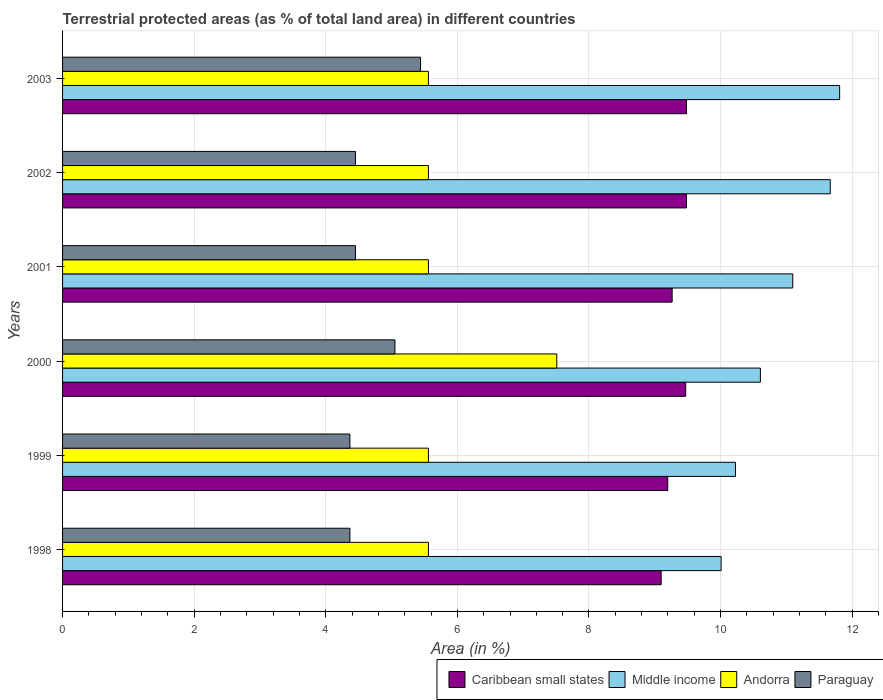How many groups of bars are there?
Keep it short and to the point. 6. Are the number of bars per tick equal to the number of legend labels?
Your answer should be very brief. Yes. How many bars are there on the 5th tick from the top?
Your answer should be very brief. 4. What is the label of the 2nd group of bars from the top?
Your answer should be very brief. 2002. In how many cases, is the number of bars for a given year not equal to the number of legend labels?
Provide a short and direct response. 0. What is the percentage of terrestrial protected land in Paraguay in 2003?
Provide a short and direct response. 5.44. Across all years, what is the maximum percentage of terrestrial protected land in Middle income?
Your answer should be compact. 11.81. Across all years, what is the minimum percentage of terrestrial protected land in Middle income?
Ensure brevity in your answer.  10.01. What is the total percentage of terrestrial protected land in Middle income in the graph?
Offer a terse response. 65.41. What is the difference between the percentage of terrestrial protected land in Andorra in 2000 and the percentage of terrestrial protected land in Middle income in 1999?
Make the answer very short. -2.72. What is the average percentage of terrestrial protected land in Caribbean small states per year?
Give a very brief answer. 9.33. In the year 2000, what is the difference between the percentage of terrestrial protected land in Middle income and percentage of terrestrial protected land in Andorra?
Your response must be concise. 3.09. In how many years, is the percentage of terrestrial protected land in Caribbean small states greater than 6.8 %?
Offer a terse response. 6. What is the ratio of the percentage of terrestrial protected land in Middle income in 1998 to that in 2003?
Offer a very short reply. 0.85. Is the percentage of terrestrial protected land in Caribbean small states in 2000 less than that in 2003?
Offer a very short reply. Yes. Is the difference between the percentage of terrestrial protected land in Middle income in 1998 and 2001 greater than the difference between the percentage of terrestrial protected land in Andorra in 1998 and 2001?
Keep it short and to the point. No. What is the difference between the highest and the second highest percentage of terrestrial protected land in Paraguay?
Your response must be concise. 0.39. What is the difference between the highest and the lowest percentage of terrestrial protected land in Andorra?
Provide a succinct answer. 1.95. What does the 2nd bar from the top in 2003 represents?
Make the answer very short. Andorra. What does the 4th bar from the bottom in 2001 represents?
Your response must be concise. Paraguay. Is it the case that in every year, the sum of the percentage of terrestrial protected land in Middle income and percentage of terrestrial protected land in Andorra is greater than the percentage of terrestrial protected land in Caribbean small states?
Provide a succinct answer. Yes. How many bars are there?
Give a very brief answer. 24. Are all the bars in the graph horizontal?
Give a very brief answer. Yes. Does the graph contain grids?
Offer a very short reply. Yes. Where does the legend appear in the graph?
Your response must be concise. Bottom right. What is the title of the graph?
Offer a very short reply. Terrestrial protected areas (as % of total land area) in different countries. Does "European Union" appear as one of the legend labels in the graph?
Your answer should be compact. No. What is the label or title of the X-axis?
Your answer should be very brief. Area (in %). What is the label or title of the Y-axis?
Your response must be concise. Years. What is the Area (in %) of Caribbean small states in 1998?
Offer a very short reply. 9.1. What is the Area (in %) of Middle income in 1998?
Provide a short and direct response. 10.01. What is the Area (in %) of Andorra in 1998?
Your answer should be compact. 5.56. What is the Area (in %) of Paraguay in 1998?
Make the answer very short. 4.37. What is the Area (in %) in Caribbean small states in 1999?
Ensure brevity in your answer.  9.2. What is the Area (in %) in Middle income in 1999?
Provide a succinct answer. 10.23. What is the Area (in %) in Andorra in 1999?
Offer a very short reply. 5.56. What is the Area (in %) of Paraguay in 1999?
Offer a very short reply. 4.37. What is the Area (in %) in Caribbean small states in 2000?
Provide a short and direct response. 9.47. What is the Area (in %) in Middle income in 2000?
Ensure brevity in your answer.  10.61. What is the Area (in %) of Andorra in 2000?
Ensure brevity in your answer.  7.51. What is the Area (in %) of Paraguay in 2000?
Keep it short and to the point. 5.05. What is the Area (in %) of Caribbean small states in 2001?
Your answer should be very brief. 9.26. What is the Area (in %) in Middle income in 2001?
Provide a succinct answer. 11.1. What is the Area (in %) in Andorra in 2001?
Offer a terse response. 5.56. What is the Area (in %) in Paraguay in 2001?
Make the answer very short. 4.45. What is the Area (in %) of Caribbean small states in 2002?
Ensure brevity in your answer.  9.48. What is the Area (in %) of Middle income in 2002?
Your answer should be compact. 11.67. What is the Area (in %) of Andorra in 2002?
Ensure brevity in your answer.  5.56. What is the Area (in %) of Paraguay in 2002?
Offer a very short reply. 4.45. What is the Area (in %) of Caribbean small states in 2003?
Offer a terse response. 9.48. What is the Area (in %) of Middle income in 2003?
Offer a very short reply. 11.81. What is the Area (in %) in Andorra in 2003?
Provide a succinct answer. 5.56. What is the Area (in %) in Paraguay in 2003?
Keep it short and to the point. 5.44. Across all years, what is the maximum Area (in %) in Caribbean small states?
Ensure brevity in your answer.  9.48. Across all years, what is the maximum Area (in %) of Middle income?
Offer a very short reply. 11.81. Across all years, what is the maximum Area (in %) in Andorra?
Ensure brevity in your answer.  7.51. Across all years, what is the maximum Area (in %) in Paraguay?
Your answer should be compact. 5.44. Across all years, what is the minimum Area (in %) in Caribbean small states?
Offer a very short reply. 9.1. Across all years, what is the minimum Area (in %) in Middle income?
Your answer should be very brief. 10.01. Across all years, what is the minimum Area (in %) in Andorra?
Your response must be concise. 5.56. Across all years, what is the minimum Area (in %) in Paraguay?
Give a very brief answer. 4.37. What is the total Area (in %) in Caribbean small states in the graph?
Ensure brevity in your answer.  55.99. What is the total Area (in %) in Middle income in the graph?
Keep it short and to the point. 65.41. What is the total Area (in %) of Andorra in the graph?
Give a very brief answer. 35.31. What is the total Area (in %) in Paraguay in the graph?
Your answer should be compact. 28.13. What is the difference between the Area (in %) of Caribbean small states in 1998 and that in 1999?
Offer a very short reply. -0.1. What is the difference between the Area (in %) of Middle income in 1998 and that in 1999?
Keep it short and to the point. -0.22. What is the difference between the Area (in %) of Caribbean small states in 1998 and that in 2000?
Give a very brief answer. -0.37. What is the difference between the Area (in %) in Middle income in 1998 and that in 2000?
Ensure brevity in your answer.  -0.6. What is the difference between the Area (in %) of Andorra in 1998 and that in 2000?
Your response must be concise. -1.95. What is the difference between the Area (in %) of Paraguay in 1998 and that in 2000?
Provide a short and direct response. -0.68. What is the difference between the Area (in %) in Caribbean small states in 1998 and that in 2001?
Make the answer very short. -0.17. What is the difference between the Area (in %) of Middle income in 1998 and that in 2001?
Your answer should be very brief. -1.09. What is the difference between the Area (in %) in Andorra in 1998 and that in 2001?
Offer a very short reply. 0. What is the difference between the Area (in %) in Paraguay in 1998 and that in 2001?
Offer a terse response. -0.08. What is the difference between the Area (in %) of Caribbean small states in 1998 and that in 2002?
Ensure brevity in your answer.  -0.39. What is the difference between the Area (in %) in Middle income in 1998 and that in 2002?
Your answer should be very brief. -1.66. What is the difference between the Area (in %) in Paraguay in 1998 and that in 2002?
Your answer should be very brief. -0.08. What is the difference between the Area (in %) in Caribbean small states in 1998 and that in 2003?
Keep it short and to the point. -0.39. What is the difference between the Area (in %) in Middle income in 1998 and that in 2003?
Your response must be concise. -1.8. What is the difference between the Area (in %) of Andorra in 1998 and that in 2003?
Offer a very short reply. 0. What is the difference between the Area (in %) in Paraguay in 1998 and that in 2003?
Offer a terse response. -1.07. What is the difference between the Area (in %) of Caribbean small states in 1999 and that in 2000?
Provide a succinct answer. -0.27. What is the difference between the Area (in %) of Middle income in 1999 and that in 2000?
Make the answer very short. -0.38. What is the difference between the Area (in %) of Andorra in 1999 and that in 2000?
Provide a short and direct response. -1.95. What is the difference between the Area (in %) of Paraguay in 1999 and that in 2000?
Ensure brevity in your answer.  -0.68. What is the difference between the Area (in %) of Caribbean small states in 1999 and that in 2001?
Offer a very short reply. -0.07. What is the difference between the Area (in %) in Middle income in 1999 and that in 2001?
Offer a very short reply. -0.87. What is the difference between the Area (in %) in Paraguay in 1999 and that in 2001?
Your answer should be very brief. -0.08. What is the difference between the Area (in %) of Caribbean small states in 1999 and that in 2002?
Offer a terse response. -0.28. What is the difference between the Area (in %) in Middle income in 1999 and that in 2002?
Give a very brief answer. -1.44. What is the difference between the Area (in %) of Andorra in 1999 and that in 2002?
Your answer should be very brief. 0. What is the difference between the Area (in %) of Paraguay in 1999 and that in 2002?
Make the answer very short. -0.08. What is the difference between the Area (in %) in Caribbean small states in 1999 and that in 2003?
Your response must be concise. -0.28. What is the difference between the Area (in %) of Middle income in 1999 and that in 2003?
Provide a short and direct response. -1.58. What is the difference between the Area (in %) in Andorra in 1999 and that in 2003?
Offer a very short reply. 0. What is the difference between the Area (in %) of Paraguay in 1999 and that in 2003?
Provide a short and direct response. -1.07. What is the difference between the Area (in %) in Caribbean small states in 2000 and that in 2001?
Ensure brevity in your answer.  0.21. What is the difference between the Area (in %) in Middle income in 2000 and that in 2001?
Your answer should be compact. -0.49. What is the difference between the Area (in %) in Andorra in 2000 and that in 2001?
Your response must be concise. 1.95. What is the difference between the Area (in %) in Paraguay in 2000 and that in 2001?
Provide a succinct answer. 0.6. What is the difference between the Area (in %) of Caribbean small states in 2000 and that in 2002?
Give a very brief answer. -0.01. What is the difference between the Area (in %) in Middle income in 2000 and that in 2002?
Make the answer very short. -1.06. What is the difference between the Area (in %) of Andorra in 2000 and that in 2002?
Provide a succinct answer. 1.95. What is the difference between the Area (in %) of Paraguay in 2000 and that in 2002?
Ensure brevity in your answer.  0.6. What is the difference between the Area (in %) in Caribbean small states in 2000 and that in 2003?
Give a very brief answer. -0.01. What is the difference between the Area (in %) of Middle income in 2000 and that in 2003?
Ensure brevity in your answer.  -1.2. What is the difference between the Area (in %) of Andorra in 2000 and that in 2003?
Ensure brevity in your answer.  1.95. What is the difference between the Area (in %) in Paraguay in 2000 and that in 2003?
Ensure brevity in your answer.  -0.39. What is the difference between the Area (in %) of Caribbean small states in 2001 and that in 2002?
Offer a very short reply. -0.22. What is the difference between the Area (in %) of Middle income in 2001 and that in 2002?
Offer a terse response. -0.57. What is the difference between the Area (in %) of Paraguay in 2001 and that in 2002?
Provide a short and direct response. 0. What is the difference between the Area (in %) of Caribbean small states in 2001 and that in 2003?
Your answer should be very brief. -0.22. What is the difference between the Area (in %) in Middle income in 2001 and that in 2003?
Provide a succinct answer. -0.71. What is the difference between the Area (in %) in Paraguay in 2001 and that in 2003?
Provide a short and direct response. -0.99. What is the difference between the Area (in %) in Middle income in 2002 and that in 2003?
Keep it short and to the point. -0.14. What is the difference between the Area (in %) in Paraguay in 2002 and that in 2003?
Provide a succinct answer. -0.99. What is the difference between the Area (in %) of Caribbean small states in 1998 and the Area (in %) of Middle income in 1999?
Make the answer very short. -1.13. What is the difference between the Area (in %) of Caribbean small states in 1998 and the Area (in %) of Andorra in 1999?
Provide a short and direct response. 3.54. What is the difference between the Area (in %) in Caribbean small states in 1998 and the Area (in %) in Paraguay in 1999?
Your answer should be very brief. 4.73. What is the difference between the Area (in %) in Middle income in 1998 and the Area (in %) in Andorra in 1999?
Keep it short and to the point. 4.45. What is the difference between the Area (in %) in Middle income in 1998 and the Area (in %) in Paraguay in 1999?
Your response must be concise. 5.64. What is the difference between the Area (in %) in Andorra in 1998 and the Area (in %) in Paraguay in 1999?
Give a very brief answer. 1.19. What is the difference between the Area (in %) of Caribbean small states in 1998 and the Area (in %) of Middle income in 2000?
Provide a short and direct response. -1.51. What is the difference between the Area (in %) in Caribbean small states in 1998 and the Area (in %) in Andorra in 2000?
Offer a very short reply. 1.59. What is the difference between the Area (in %) of Caribbean small states in 1998 and the Area (in %) of Paraguay in 2000?
Give a very brief answer. 4.05. What is the difference between the Area (in %) in Middle income in 1998 and the Area (in %) in Andorra in 2000?
Your answer should be very brief. 2.5. What is the difference between the Area (in %) in Middle income in 1998 and the Area (in %) in Paraguay in 2000?
Offer a very short reply. 4.96. What is the difference between the Area (in %) in Andorra in 1998 and the Area (in %) in Paraguay in 2000?
Your answer should be compact. 0.51. What is the difference between the Area (in %) in Caribbean small states in 1998 and the Area (in %) in Middle income in 2001?
Provide a succinct answer. -2. What is the difference between the Area (in %) in Caribbean small states in 1998 and the Area (in %) in Andorra in 2001?
Your response must be concise. 3.54. What is the difference between the Area (in %) in Caribbean small states in 1998 and the Area (in %) in Paraguay in 2001?
Keep it short and to the point. 4.65. What is the difference between the Area (in %) in Middle income in 1998 and the Area (in %) in Andorra in 2001?
Give a very brief answer. 4.45. What is the difference between the Area (in %) in Middle income in 1998 and the Area (in %) in Paraguay in 2001?
Offer a very short reply. 5.56. What is the difference between the Area (in %) in Andorra in 1998 and the Area (in %) in Paraguay in 2001?
Offer a terse response. 1.11. What is the difference between the Area (in %) in Caribbean small states in 1998 and the Area (in %) in Middle income in 2002?
Give a very brief answer. -2.57. What is the difference between the Area (in %) of Caribbean small states in 1998 and the Area (in %) of Andorra in 2002?
Your response must be concise. 3.54. What is the difference between the Area (in %) in Caribbean small states in 1998 and the Area (in %) in Paraguay in 2002?
Keep it short and to the point. 4.65. What is the difference between the Area (in %) in Middle income in 1998 and the Area (in %) in Andorra in 2002?
Offer a terse response. 4.45. What is the difference between the Area (in %) in Middle income in 1998 and the Area (in %) in Paraguay in 2002?
Offer a terse response. 5.56. What is the difference between the Area (in %) of Andorra in 1998 and the Area (in %) of Paraguay in 2002?
Provide a succinct answer. 1.11. What is the difference between the Area (in %) in Caribbean small states in 1998 and the Area (in %) in Middle income in 2003?
Offer a very short reply. -2.71. What is the difference between the Area (in %) of Caribbean small states in 1998 and the Area (in %) of Andorra in 2003?
Offer a terse response. 3.54. What is the difference between the Area (in %) in Caribbean small states in 1998 and the Area (in %) in Paraguay in 2003?
Your answer should be compact. 3.66. What is the difference between the Area (in %) of Middle income in 1998 and the Area (in %) of Andorra in 2003?
Offer a terse response. 4.45. What is the difference between the Area (in %) of Middle income in 1998 and the Area (in %) of Paraguay in 2003?
Make the answer very short. 4.57. What is the difference between the Area (in %) of Andorra in 1998 and the Area (in %) of Paraguay in 2003?
Provide a succinct answer. 0.12. What is the difference between the Area (in %) in Caribbean small states in 1999 and the Area (in %) in Middle income in 2000?
Your answer should be very brief. -1.41. What is the difference between the Area (in %) of Caribbean small states in 1999 and the Area (in %) of Andorra in 2000?
Keep it short and to the point. 1.69. What is the difference between the Area (in %) of Caribbean small states in 1999 and the Area (in %) of Paraguay in 2000?
Your answer should be compact. 4.15. What is the difference between the Area (in %) in Middle income in 1999 and the Area (in %) in Andorra in 2000?
Give a very brief answer. 2.72. What is the difference between the Area (in %) in Middle income in 1999 and the Area (in %) in Paraguay in 2000?
Offer a terse response. 5.18. What is the difference between the Area (in %) in Andorra in 1999 and the Area (in %) in Paraguay in 2000?
Ensure brevity in your answer.  0.51. What is the difference between the Area (in %) in Caribbean small states in 1999 and the Area (in %) in Middle income in 2001?
Offer a very short reply. -1.9. What is the difference between the Area (in %) of Caribbean small states in 1999 and the Area (in %) of Andorra in 2001?
Offer a terse response. 3.64. What is the difference between the Area (in %) in Caribbean small states in 1999 and the Area (in %) in Paraguay in 2001?
Make the answer very short. 4.75. What is the difference between the Area (in %) of Middle income in 1999 and the Area (in %) of Andorra in 2001?
Provide a short and direct response. 4.67. What is the difference between the Area (in %) in Middle income in 1999 and the Area (in %) in Paraguay in 2001?
Ensure brevity in your answer.  5.78. What is the difference between the Area (in %) in Andorra in 1999 and the Area (in %) in Paraguay in 2001?
Your answer should be compact. 1.11. What is the difference between the Area (in %) in Caribbean small states in 1999 and the Area (in %) in Middle income in 2002?
Your answer should be very brief. -2.47. What is the difference between the Area (in %) of Caribbean small states in 1999 and the Area (in %) of Andorra in 2002?
Provide a succinct answer. 3.64. What is the difference between the Area (in %) of Caribbean small states in 1999 and the Area (in %) of Paraguay in 2002?
Provide a succinct answer. 4.75. What is the difference between the Area (in %) in Middle income in 1999 and the Area (in %) in Andorra in 2002?
Your response must be concise. 4.67. What is the difference between the Area (in %) in Middle income in 1999 and the Area (in %) in Paraguay in 2002?
Ensure brevity in your answer.  5.78. What is the difference between the Area (in %) in Andorra in 1999 and the Area (in %) in Paraguay in 2002?
Your response must be concise. 1.11. What is the difference between the Area (in %) of Caribbean small states in 1999 and the Area (in %) of Middle income in 2003?
Ensure brevity in your answer.  -2.61. What is the difference between the Area (in %) in Caribbean small states in 1999 and the Area (in %) in Andorra in 2003?
Your response must be concise. 3.64. What is the difference between the Area (in %) in Caribbean small states in 1999 and the Area (in %) in Paraguay in 2003?
Your answer should be very brief. 3.76. What is the difference between the Area (in %) of Middle income in 1999 and the Area (in %) of Andorra in 2003?
Provide a short and direct response. 4.67. What is the difference between the Area (in %) in Middle income in 1999 and the Area (in %) in Paraguay in 2003?
Your answer should be very brief. 4.79. What is the difference between the Area (in %) of Andorra in 1999 and the Area (in %) of Paraguay in 2003?
Your answer should be compact. 0.12. What is the difference between the Area (in %) in Caribbean small states in 2000 and the Area (in %) in Middle income in 2001?
Your response must be concise. -1.63. What is the difference between the Area (in %) in Caribbean small states in 2000 and the Area (in %) in Andorra in 2001?
Keep it short and to the point. 3.91. What is the difference between the Area (in %) in Caribbean small states in 2000 and the Area (in %) in Paraguay in 2001?
Make the answer very short. 5.02. What is the difference between the Area (in %) of Middle income in 2000 and the Area (in %) of Andorra in 2001?
Offer a very short reply. 5.04. What is the difference between the Area (in %) of Middle income in 2000 and the Area (in %) of Paraguay in 2001?
Your response must be concise. 6.15. What is the difference between the Area (in %) in Andorra in 2000 and the Area (in %) in Paraguay in 2001?
Provide a short and direct response. 3.06. What is the difference between the Area (in %) in Caribbean small states in 2000 and the Area (in %) in Middle income in 2002?
Keep it short and to the point. -2.2. What is the difference between the Area (in %) of Caribbean small states in 2000 and the Area (in %) of Andorra in 2002?
Offer a very short reply. 3.91. What is the difference between the Area (in %) in Caribbean small states in 2000 and the Area (in %) in Paraguay in 2002?
Ensure brevity in your answer.  5.02. What is the difference between the Area (in %) in Middle income in 2000 and the Area (in %) in Andorra in 2002?
Your response must be concise. 5.04. What is the difference between the Area (in %) in Middle income in 2000 and the Area (in %) in Paraguay in 2002?
Offer a very short reply. 6.15. What is the difference between the Area (in %) in Andorra in 2000 and the Area (in %) in Paraguay in 2002?
Your answer should be compact. 3.06. What is the difference between the Area (in %) of Caribbean small states in 2000 and the Area (in %) of Middle income in 2003?
Provide a succinct answer. -2.34. What is the difference between the Area (in %) of Caribbean small states in 2000 and the Area (in %) of Andorra in 2003?
Your response must be concise. 3.91. What is the difference between the Area (in %) of Caribbean small states in 2000 and the Area (in %) of Paraguay in 2003?
Provide a succinct answer. 4.03. What is the difference between the Area (in %) of Middle income in 2000 and the Area (in %) of Andorra in 2003?
Ensure brevity in your answer.  5.04. What is the difference between the Area (in %) in Middle income in 2000 and the Area (in %) in Paraguay in 2003?
Give a very brief answer. 5.16. What is the difference between the Area (in %) of Andorra in 2000 and the Area (in %) of Paraguay in 2003?
Your answer should be very brief. 2.07. What is the difference between the Area (in %) in Caribbean small states in 2001 and the Area (in %) in Middle income in 2002?
Give a very brief answer. -2.4. What is the difference between the Area (in %) of Caribbean small states in 2001 and the Area (in %) of Andorra in 2002?
Offer a very short reply. 3.7. What is the difference between the Area (in %) of Caribbean small states in 2001 and the Area (in %) of Paraguay in 2002?
Offer a terse response. 4.81. What is the difference between the Area (in %) in Middle income in 2001 and the Area (in %) in Andorra in 2002?
Offer a very short reply. 5.54. What is the difference between the Area (in %) in Middle income in 2001 and the Area (in %) in Paraguay in 2002?
Keep it short and to the point. 6.65. What is the difference between the Area (in %) of Andorra in 2001 and the Area (in %) of Paraguay in 2002?
Your response must be concise. 1.11. What is the difference between the Area (in %) in Caribbean small states in 2001 and the Area (in %) in Middle income in 2003?
Ensure brevity in your answer.  -2.55. What is the difference between the Area (in %) in Caribbean small states in 2001 and the Area (in %) in Andorra in 2003?
Keep it short and to the point. 3.7. What is the difference between the Area (in %) of Caribbean small states in 2001 and the Area (in %) of Paraguay in 2003?
Offer a terse response. 3.82. What is the difference between the Area (in %) of Middle income in 2001 and the Area (in %) of Andorra in 2003?
Give a very brief answer. 5.54. What is the difference between the Area (in %) in Middle income in 2001 and the Area (in %) in Paraguay in 2003?
Make the answer very short. 5.66. What is the difference between the Area (in %) of Andorra in 2001 and the Area (in %) of Paraguay in 2003?
Provide a short and direct response. 0.12. What is the difference between the Area (in %) in Caribbean small states in 2002 and the Area (in %) in Middle income in 2003?
Keep it short and to the point. -2.33. What is the difference between the Area (in %) of Caribbean small states in 2002 and the Area (in %) of Andorra in 2003?
Offer a terse response. 3.92. What is the difference between the Area (in %) in Caribbean small states in 2002 and the Area (in %) in Paraguay in 2003?
Provide a succinct answer. 4.04. What is the difference between the Area (in %) of Middle income in 2002 and the Area (in %) of Andorra in 2003?
Make the answer very short. 6.11. What is the difference between the Area (in %) in Middle income in 2002 and the Area (in %) in Paraguay in 2003?
Ensure brevity in your answer.  6.23. What is the difference between the Area (in %) in Andorra in 2002 and the Area (in %) in Paraguay in 2003?
Ensure brevity in your answer.  0.12. What is the average Area (in %) of Caribbean small states per year?
Ensure brevity in your answer.  9.33. What is the average Area (in %) in Middle income per year?
Give a very brief answer. 10.9. What is the average Area (in %) of Andorra per year?
Give a very brief answer. 5.89. What is the average Area (in %) of Paraguay per year?
Keep it short and to the point. 4.69. In the year 1998, what is the difference between the Area (in %) in Caribbean small states and Area (in %) in Middle income?
Your answer should be compact. -0.91. In the year 1998, what is the difference between the Area (in %) of Caribbean small states and Area (in %) of Andorra?
Your response must be concise. 3.54. In the year 1998, what is the difference between the Area (in %) in Caribbean small states and Area (in %) in Paraguay?
Provide a succinct answer. 4.73. In the year 1998, what is the difference between the Area (in %) of Middle income and Area (in %) of Andorra?
Make the answer very short. 4.45. In the year 1998, what is the difference between the Area (in %) of Middle income and Area (in %) of Paraguay?
Keep it short and to the point. 5.64. In the year 1998, what is the difference between the Area (in %) in Andorra and Area (in %) in Paraguay?
Offer a terse response. 1.19. In the year 1999, what is the difference between the Area (in %) in Caribbean small states and Area (in %) in Middle income?
Give a very brief answer. -1.03. In the year 1999, what is the difference between the Area (in %) in Caribbean small states and Area (in %) in Andorra?
Provide a short and direct response. 3.64. In the year 1999, what is the difference between the Area (in %) of Caribbean small states and Area (in %) of Paraguay?
Your answer should be compact. 4.83. In the year 1999, what is the difference between the Area (in %) of Middle income and Area (in %) of Andorra?
Provide a succinct answer. 4.67. In the year 1999, what is the difference between the Area (in %) in Middle income and Area (in %) in Paraguay?
Make the answer very short. 5.86. In the year 1999, what is the difference between the Area (in %) of Andorra and Area (in %) of Paraguay?
Provide a succinct answer. 1.19. In the year 2000, what is the difference between the Area (in %) in Caribbean small states and Area (in %) in Middle income?
Your answer should be very brief. -1.14. In the year 2000, what is the difference between the Area (in %) of Caribbean small states and Area (in %) of Andorra?
Your response must be concise. 1.96. In the year 2000, what is the difference between the Area (in %) in Caribbean small states and Area (in %) in Paraguay?
Your answer should be very brief. 4.42. In the year 2000, what is the difference between the Area (in %) in Middle income and Area (in %) in Andorra?
Offer a terse response. 3.09. In the year 2000, what is the difference between the Area (in %) in Middle income and Area (in %) in Paraguay?
Your answer should be compact. 5.55. In the year 2000, what is the difference between the Area (in %) of Andorra and Area (in %) of Paraguay?
Keep it short and to the point. 2.46. In the year 2001, what is the difference between the Area (in %) in Caribbean small states and Area (in %) in Middle income?
Ensure brevity in your answer.  -1.83. In the year 2001, what is the difference between the Area (in %) of Caribbean small states and Area (in %) of Andorra?
Ensure brevity in your answer.  3.7. In the year 2001, what is the difference between the Area (in %) of Caribbean small states and Area (in %) of Paraguay?
Your answer should be compact. 4.81. In the year 2001, what is the difference between the Area (in %) in Middle income and Area (in %) in Andorra?
Offer a terse response. 5.54. In the year 2001, what is the difference between the Area (in %) in Middle income and Area (in %) in Paraguay?
Your response must be concise. 6.65. In the year 2001, what is the difference between the Area (in %) of Andorra and Area (in %) of Paraguay?
Provide a short and direct response. 1.11. In the year 2002, what is the difference between the Area (in %) in Caribbean small states and Area (in %) in Middle income?
Make the answer very short. -2.18. In the year 2002, what is the difference between the Area (in %) in Caribbean small states and Area (in %) in Andorra?
Offer a terse response. 3.92. In the year 2002, what is the difference between the Area (in %) of Caribbean small states and Area (in %) of Paraguay?
Give a very brief answer. 5.03. In the year 2002, what is the difference between the Area (in %) in Middle income and Area (in %) in Andorra?
Ensure brevity in your answer.  6.11. In the year 2002, what is the difference between the Area (in %) of Middle income and Area (in %) of Paraguay?
Make the answer very short. 7.22. In the year 2002, what is the difference between the Area (in %) in Andorra and Area (in %) in Paraguay?
Keep it short and to the point. 1.11. In the year 2003, what is the difference between the Area (in %) of Caribbean small states and Area (in %) of Middle income?
Ensure brevity in your answer.  -2.33. In the year 2003, what is the difference between the Area (in %) in Caribbean small states and Area (in %) in Andorra?
Make the answer very short. 3.92. In the year 2003, what is the difference between the Area (in %) of Caribbean small states and Area (in %) of Paraguay?
Keep it short and to the point. 4.04. In the year 2003, what is the difference between the Area (in %) of Middle income and Area (in %) of Andorra?
Your response must be concise. 6.25. In the year 2003, what is the difference between the Area (in %) of Middle income and Area (in %) of Paraguay?
Offer a terse response. 6.37. In the year 2003, what is the difference between the Area (in %) of Andorra and Area (in %) of Paraguay?
Your response must be concise. 0.12. What is the ratio of the Area (in %) of Middle income in 1998 to that in 1999?
Provide a succinct answer. 0.98. What is the ratio of the Area (in %) in Andorra in 1998 to that in 1999?
Make the answer very short. 1. What is the ratio of the Area (in %) in Paraguay in 1998 to that in 1999?
Offer a terse response. 1. What is the ratio of the Area (in %) in Caribbean small states in 1998 to that in 2000?
Provide a short and direct response. 0.96. What is the ratio of the Area (in %) of Middle income in 1998 to that in 2000?
Offer a terse response. 0.94. What is the ratio of the Area (in %) of Andorra in 1998 to that in 2000?
Provide a short and direct response. 0.74. What is the ratio of the Area (in %) in Paraguay in 1998 to that in 2000?
Keep it short and to the point. 0.86. What is the ratio of the Area (in %) of Caribbean small states in 1998 to that in 2001?
Offer a terse response. 0.98. What is the ratio of the Area (in %) in Middle income in 1998 to that in 2001?
Make the answer very short. 0.9. What is the ratio of the Area (in %) of Paraguay in 1998 to that in 2001?
Ensure brevity in your answer.  0.98. What is the ratio of the Area (in %) in Caribbean small states in 1998 to that in 2002?
Your answer should be compact. 0.96. What is the ratio of the Area (in %) of Middle income in 1998 to that in 2002?
Offer a very short reply. 0.86. What is the ratio of the Area (in %) in Andorra in 1998 to that in 2002?
Provide a succinct answer. 1. What is the ratio of the Area (in %) of Caribbean small states in 1998 to that in 2003?
Offer a terse response. 0.96. What is the ratio of the Area (in %) in Middle income in 1998 to that in 2003?
Keep it short and to the point. 0.85. What is the ratio of the Area (in %) in Paraguay in 1998 to that in 2003?
Your response must be concise. 0.8. What is the ratio of the Area (in %) of Caribbean small states in 1999 to that in 2000?
Keep it short and to the point. 0.97. What is the ratio of the Area (in %) of Middle income in 1999 to that in 2000?
Offer a very short reply. 0.96. What is the ratio of the Area (in %) of Andorra in 1999 to that in 2000?
Your answer should be very brief. 0.74. What is the ratio of the Area (in %) of Paraguay in 1999 to that in 2000?
Offer a very short reply. 0.86. What is the ratio of the Area (in %) in Caribbean small states in 1999 to that in 2001?
Offer a very short reply. 0.99. What is the ratio of the Area (in %) in Middle income in 1999 to that in 2001?
Ensure brevity in your answer.  0.92. What is the ratio of the Area (in %) of Middle income in 1999 to that in 2002?
Ensure brevity in your answer.  0.88. What is the ratio of the Area (in %) of Paraguay in 1999 to that in 2002?
Ensure brevity in your answer.  0.98. What is the ratio of the Area (in %) in Caribbean small states in 1999 to that in 2003?
Provide a short and direct response. 0.97. What is the ratio of the Area (in %) of Middle income in 1999 to that in 2003?
Provide a succinct answer. 0.87. What is the ratio of the Area (in %) of Andorra in 1999 to that in 2003?
Provide a succinct answer. 1. What is the ratio of the Area (in %) in Paraguay in 1999 to that in 2003?
Your answer should be compact. 0.8. What is the ratio of the Area (in %) in Caribbean small states in 2000 to that in 2001?
Your answer should be very brief. 1.02. What is the ratio of the Area (in %) of Middle income in 2000 to that in 2001?
Offer a very short reply. 0.96. What is the ratio of the Area (in %) of Andorra in 2000 to that in 2001?
Your response must be concise. 1.35. What is the ratio of the Area (in %) in Paraguay in 2000 to that in 2001?
Give a very brief answer. 1.13. What is the ratio of the Area (in %) of Caribbean small states in 2000 to that in 2002?
Your answer should be very brief. 1. What is the ratio of the Area (in %) of Middle income in 2000 to that in 2002?
Ensure brevity in your answer.  0.91. What is the ratio of the Area (in %) of Andorra in 2000 to that in 2002?
Your answer should be very brief. 1.35. What is the ratio of the Area (in %) of Paraguay in 2000 to that in 2002?
Make the answer very short. 1.13. What is the ratio of the Area (in %) in Caribbean small states in 2000 to that in 2003?
Make the answer very short. 1. What is the ratio of the Area (in %) of Middle income in 2000 to that in 2003?
Give a very brief answer. 0.9. What is the ratio of the Area (in %) in Andorra in 2000 to that in 2003?
Your response must be concise. 1.35. What is the ratio of the Area (in %) of Paraguay in 2000 to that in 2003?
Make the answer very short. 0.93. What is the ratio of the Area (in %) of Caribbean small states in 2001 to that in 2002?
Your answer should be compact. 0.98. What is the ratio of the Area (in %) of Middle income in 2001 to that in 2002?
Give a very brief answer. 0.95. What is the ratio of the Area (in %) in Caribbean small states in 2001 to that in 2003?
Ensure brevity in your answer.  0.98. What is the ratio of the Area (in %) in Middle income in 2001 to that in 2003?
Provide a short and direct response. 0.94. What is the ratio of the Area (in %) in Paraguay in 2001 to that in 2003?
Provide a succinct answer. 0.82. What is the ratio of the Area (in %) in Middle income in 2002 to that in 2003?
Your answer should be compact. 0.99. What is the ratio of the Area (in %) of Paraguay in 2002 to that in 2003?
Make the answer very short. 0.82. What is the difference between the highest and the second highest Area (in %) of Caribbean small states?
Provide a short and direct response. 0. What is the difference between the highest and the second highest Area (in %) in Middle income?
Keep it short and to the point. 0.14. What is the difference between the highest and the second highest Area (in %) of Andorra?
Provide a short and direct response. 1.95. What is the difference between the highest and the second highest Area (in %) in Paraguay?
Provide a succinct answer. 0.39. What is the difference between the highest and the lowest Area (in %) in Caribbean small states?
Your answer should be very brief. 0.39. What is the difference between the highest and the lowest Area (in %) of Middle income?
Your answer should be very brief. 1.8. What is the difference between the highest and the lowest Area (in %) of Andorra?
Keep it short and to the point. 1.95. What is the difference between the highest and the lowest Area (in %) of Paraguay?
Give a very brief answer. 1.07. 